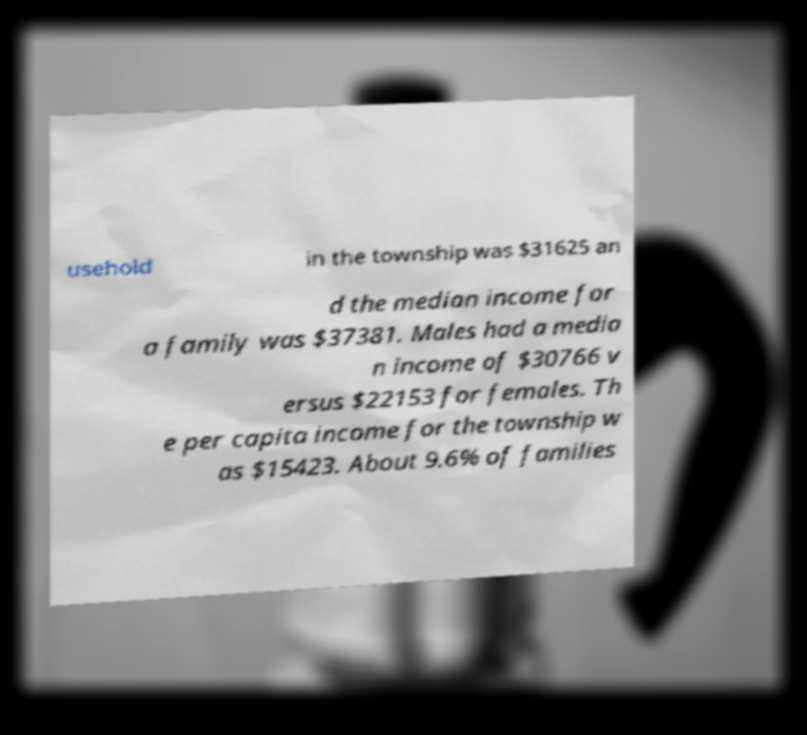Could you assist in decoding the text presented in this image and type it out clearly? usehold in the township was $31625 an d the median income for a family was $37381. Males had a media n income of $30766 v ersus $22153 for females. Th e per capita income for the township w as $15423. About 9.6% of families 